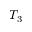<formula> <loc_0><loc_0><loc_500><loc_500>T _ { 3 }</formula> 